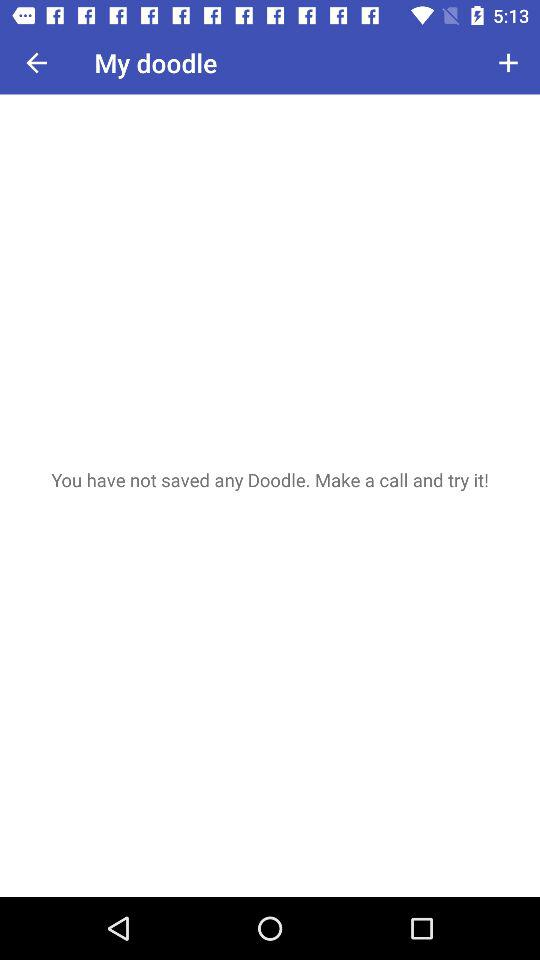Do you have any saved doodle? You do not have any saved doodle. 